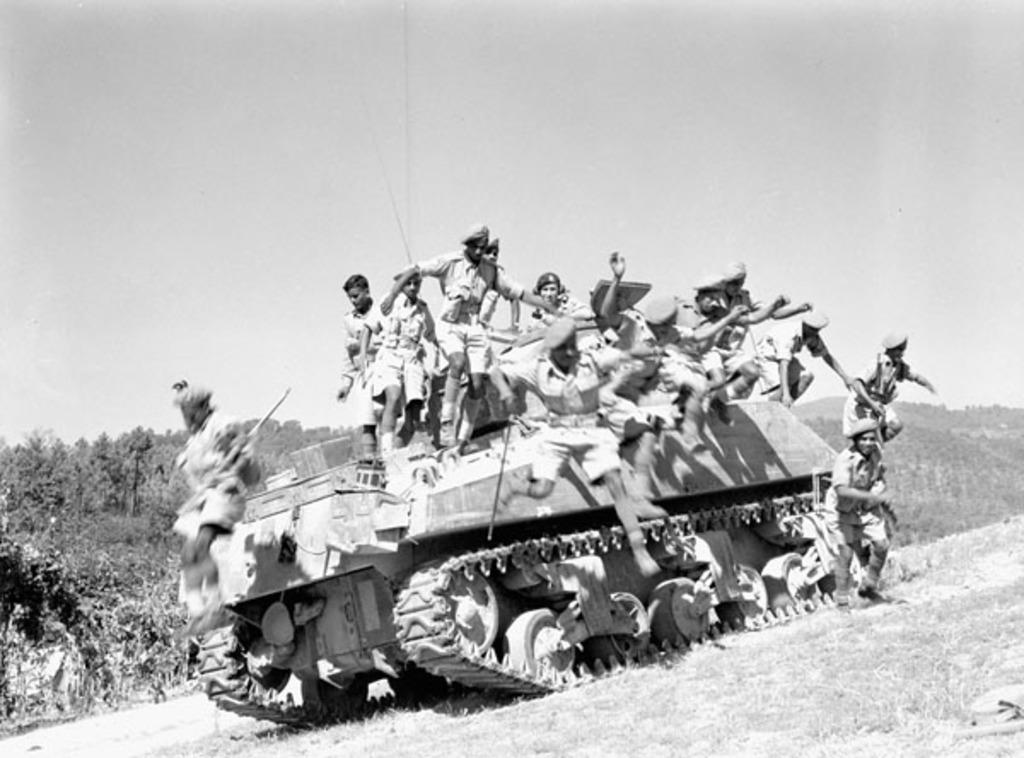What type of photograph is the image? The image is a black and white photograph. What is the main subject of the photograph? There is a military tank in the image. What are the soldiers doing in the image? There are soldiers jumping from the top of the tank. What can be seen in the background of the photograph? There are trees visible in the background of the image. What type of fan is visible in the image? There is no fan present in the image. What class of soldiers are depicted in the image? The image does not specify the class or type of soldiers; it only shows them jumping from the tank. 